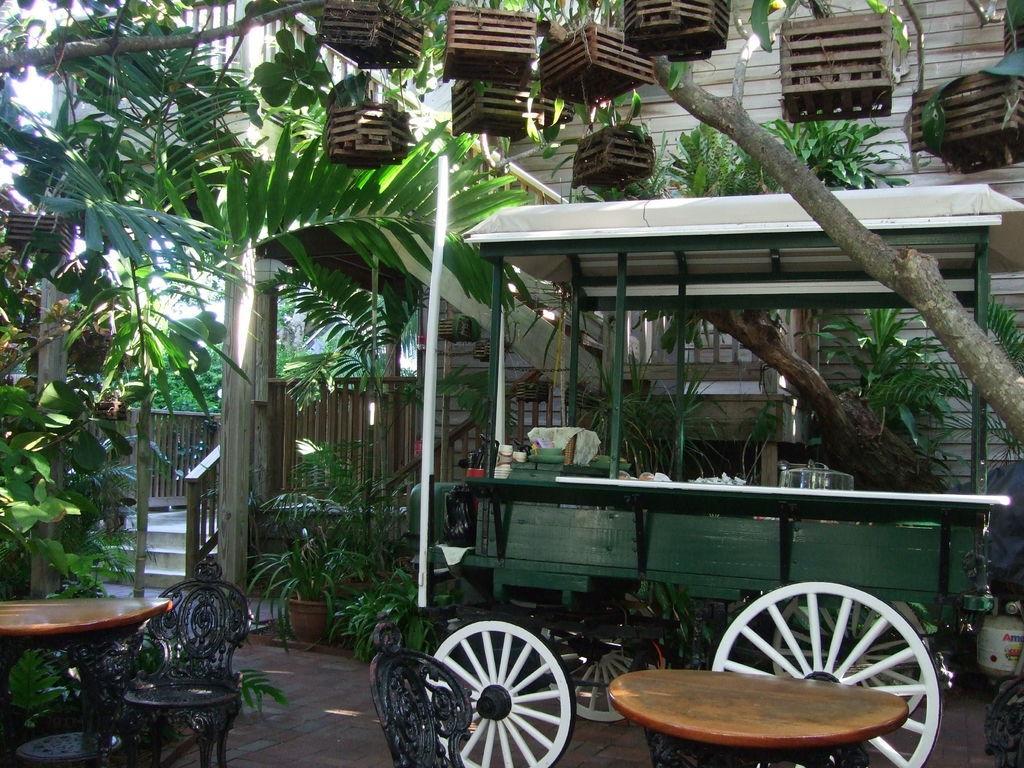How would you summarize this image in a sentence or two? In this image I see a cart vehicle and few tables and chairs. In the background I see the plants. 